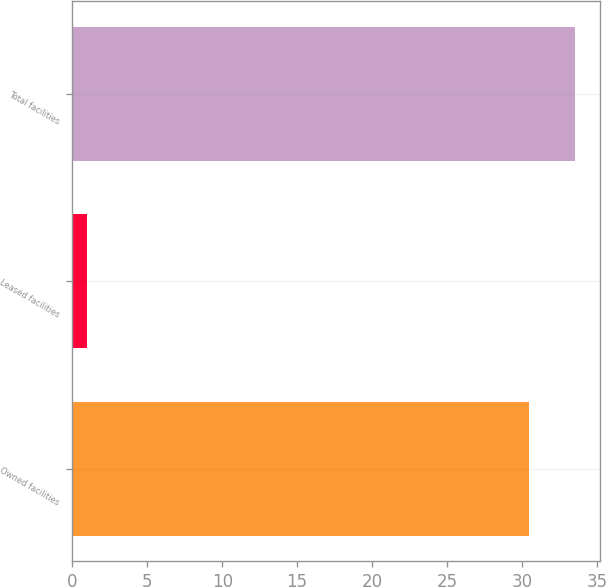Convert chart to OTSL. <chart><loc_0><loc_0><loc_500><loc_500><bar_chart><fcel>Owned facilities<fcel>Leased facilities<fcel>Total facilities<nl><fcel>30.5<fcel>1<fcel>33.55<nl></chart> 